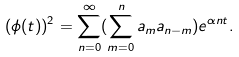Convert formula to latex. <formula><loc_0><loc_0><loc_500><loc_500>( \phi ( t ) ) ^ { 2 } = \sum _ { n = 0 } ^ { \infty } ( \sum _ { m = 0 } ^ { n } a _ { m } a _ { n - m } ) e ^ { \alpha n t } .</formula> 